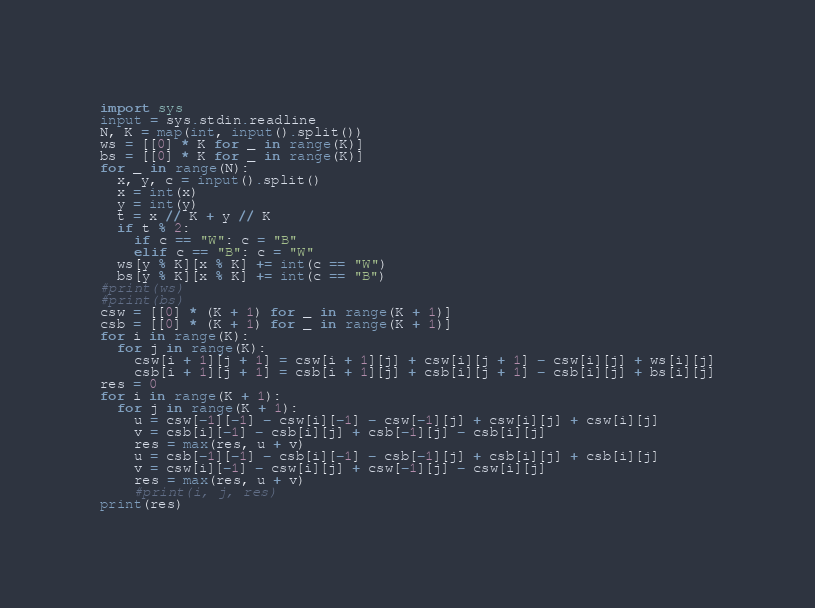<code> <loc_0><loc_0><loc_500><loc_500><_Python_>import sys
input = sys.stdin.readline
N, K = map(int, input().split())
ws = [[0] * K for _ in range(K)]
bs = [[0] * K for _ in range(K)]
for _ in range(N):
  x, y, c = input().split()
  x = int(x)
  y = int(y)
  t = x // K + y // K
  if t % 2:
    if c == "W": c = "B"
    elif c == "B": c = "W"
  ws[y % K][x % K] += int(c == "W")
  bs[y % K][x % K] += int(c == "B")
#print(ws)
#print(bs)
csw = [[0] * (K + 1) for _ in range(K + 1)]
csb = [[0] * (K + 1) for _ in range(K + 1)]
for i in range(K):
  for j in range(K):
    csw[i + 1][j + 1] = csw[i + 1][j] + csw[i][j + 1] - csw[i][j] + ws[i][j]
    csb[i + 1][j + 1] = csb[i + 1][j] + csb[i][j + 1] - csb[i][j] + bs[i][j]
res = 0
for i in range(K + 1):
  for j in range(K + 1):
    u = csw[-1][-1] - csw[i][-1] - csw[-1][j] + csw[i][j] + csw[i][j]
    v = csb[i][-1] - csb[i][j] + csb[-1][j] - csb[i][j]
    res = max(res, u + v)
    u = csb[-1][-1] - csb[i][-1] - csb[-1][j] + csb[i][j] + csb[i][j]
    v = csw[i][-1] - csw[i][j] + csw[-1][j] - csw[i][j]
    res = max(res, u + v)
    #print(i, j, res)
print(res)</code> 